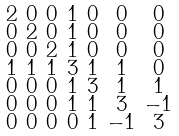<formula> <loc_0><loc_0><loc_500><loc_500>\begin{smallmatrix} 2 & 0 & 0 & 1 & 0 & 0 & 0 \\ 0 & 2 & 0 & 1 & 0 & 0 & 0 \\ 0 & 0 & 2 & 1 & 0 & 0 & 0 \\ 1 & 1 & 1 & 3 & 1 & 1 & 0 \\ 0 & 0 & 0 & 1 & 3 & 1 & 1 \\ 0 & 0 & 0 & 1 & 1 & 3 & - 1 \\ 0 & 0 & 0 & 0 & 1 & - 1 & 3 \end{smallmatrix}</formula> 